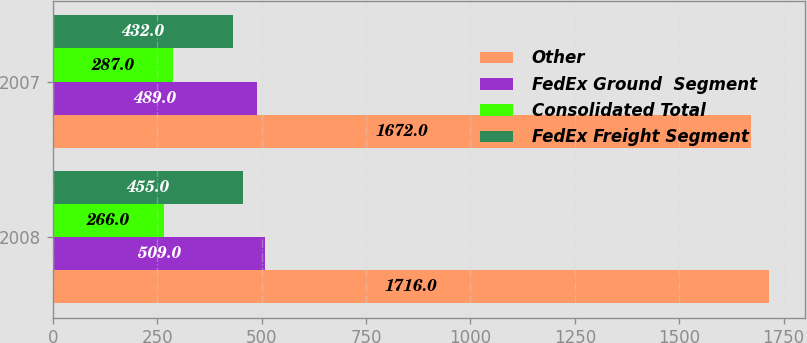Convert chart. <chart><loc_0><loc_0><loc_500><loc_500><stacked_bar_chart><ecel><fcel>2008<fcel>2007<nl><fcel>Other<fcel>1716<fcel>1672<nl><fcel>FedEx Ground  Segment<fcel>509<fcel>489<nl><fcel>Consolidated Total<fcel>266<fcel>287<nl><fcel>FedEx Freight Segment<fcel>455<fcel>432<nl></chart> 